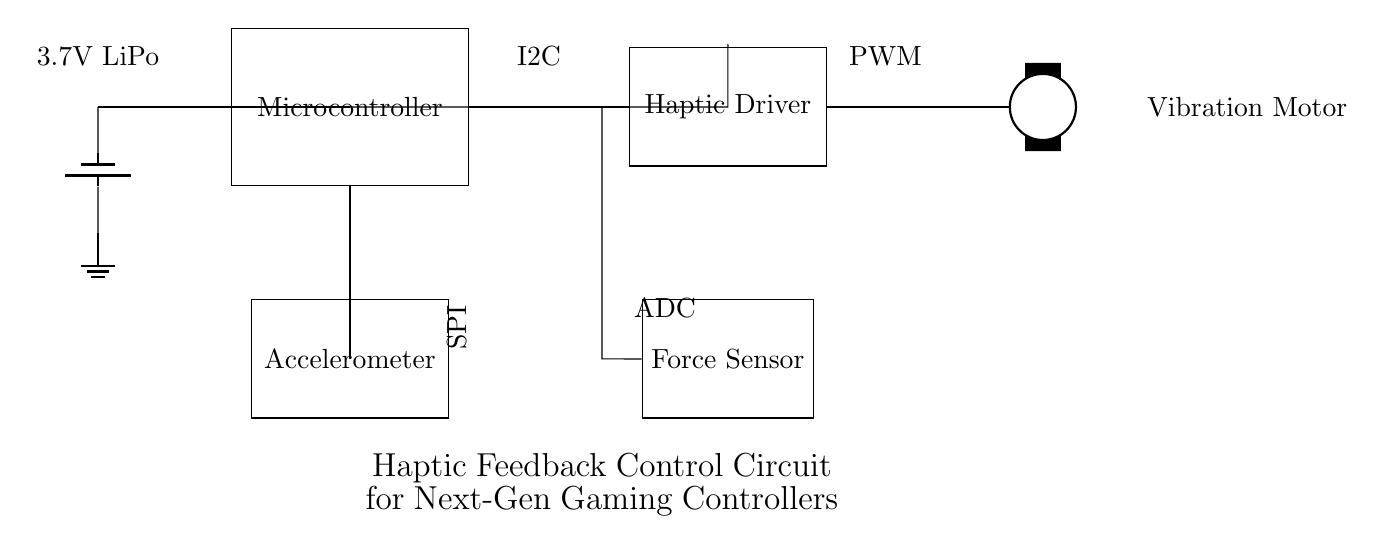What is the main component of this circuit? The main component is the Microcontroller, which coordinates the other components for haptic feedback.
Answer: Microcontroller What type of sensor is used in this circuit? The circuit uses an Accelerometer, which measures the acceleration and provides feedback on motion.
Answer: Accelerometer How is the haptic driver controlled? The haptic driver is controlled using PWM, which stands for Pulse Width Modulation, allowing variable speed control of the vibration motor.
Answer: PWM What is the power supply voltage? The power supply voltage is 3.7V, provided by a LiPo battery that powers the entire circuit.
Answer: 3.7V Which sensor provides analog data to the microcontroller? The Force Sensor provides analog data via an ADC (Analog to Digital Converter) interface connected to the microcontroller.
Answer: Force Sensor How are the components connected to the power supply? All components are connected by a common ground, with the microcontroller and other components receiving power through a series of branches from the battery.
Answer: Common ground 